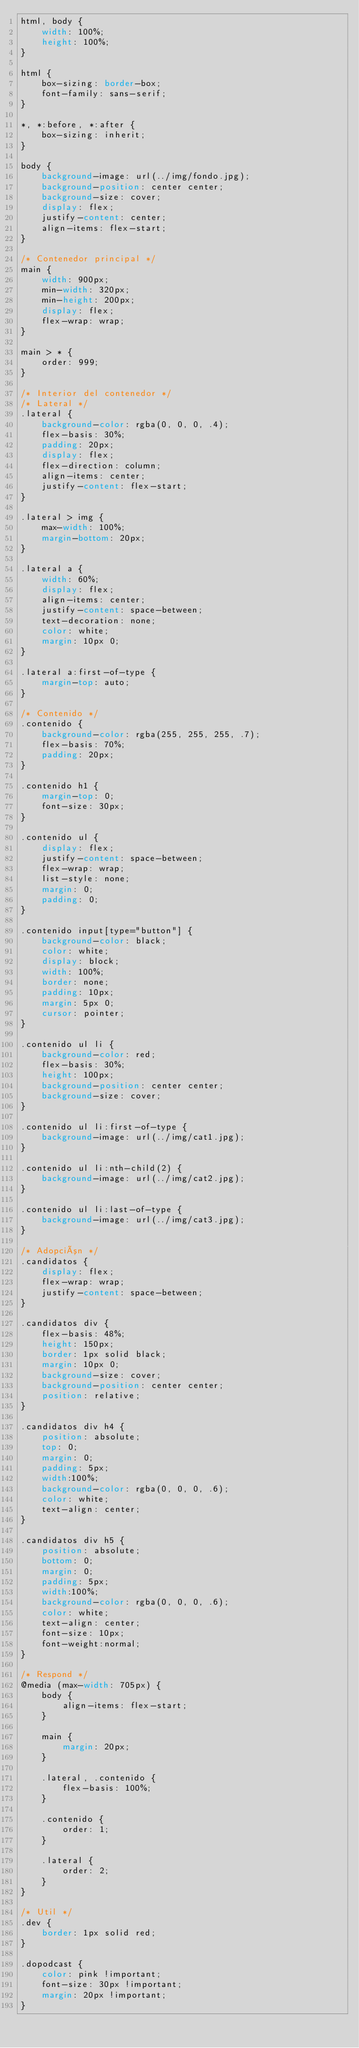<code> <loc_0><loc_0><loc_500><loc_500><_CSS_>html, body {
    width: 100%;
    height: 100%;
}

html {
    box-sizing: border-box;
    font-family: sans-serif;
}

*, *:before, *:after {
    box-sizing: inherit;
}

body {
    background-image: url(../img/fondo.jpg);
    background-position: center center;
    background-size: cover;
    display: flex;
    justify-content: center;
    align-items: flex-start;
}

/* Contenedor principal */
main {
    width: 900px;
    min-width: 320px;
    min-height: 200px;
    display: flex;
    flex-wrap: wrap;
}

main > * {
    order: 999;
}

/* Interior del contenedor */
/* Lateral */
.lateral {
    background-color: rgba(0, 0, 0, .4);
    flex-basis: 30%;
    padding: 20px;
    display: flex;
    flex-direction: column;
    align-items: center;
    justify-content: flex-start;
}

.lateral > img {
    max-width: 100%;
    margin-bottom: 20px;
}

.lateral a {
    width: 60%;
    display: flex;
    align-items: center;
    justify-content: space-between;
    text-decoration: none;
    color: white;
    margin: 10px 0;
}

.lateral a:first-of-type {
    margin-top: auto;
}

/* Contenido */
.contenido {
    background-color: rgba(255, 255, 255, .7);
    flex-basis: 70%;
    padding: 20px;
}

.contenido h1 {
    margin-top: 0;
    font-size: 30px;
}

.contenido ul {
    display: flex;
    justify-content: space-between;
    flex-wrap: wrap;
    list-style: none;
    margin: 0;
    padding: 0;
}

.contenido input[type="button"] {
    background-color: black;
    color: white;
    display: block;
    width: 100%;
    border: none;
    padding: 10px;
    margin: 5px 0;
    cursor: pointer;
}

.contenido ul li {
    background-color: red;
    flex-basis: 30%;
    height: 100px;
    background-position: center center;
    background-size: cover;
}

.contenido ul li:first-of-type {
    background-image: url(../img/cat1.jpg);
}

.contenido ul li:nth-child(2) {
    background-image: url(../img/cat2.jpg);
}

.contenido ul li:last-of-type {
    background-image: url(../img/cat3.jpg);
}

/* Adopción */
.candidatos {
    display: flex;
    flex-wrap: wrap;
    justify-content: space-between;
}

.candidatos div {
    flex-basis: 48%;
    height: 150px;
    border: 1px solid black;
    margin: 10px 0;
    background-size: cover;
    background-position: center center;
    position: relative;
}

.candidatos div h4 {
    position: absolute;
    top: 0;
    margin: 0;
    padding: 5px;
    width:100%;
    background-color: rgba(0, 0, 0, .6);
    color: white;
    text-align: center;
}

.candidatos div h5 {
    position: absolute;
    bottom: 0;
    margin: 0;
    padding: 5px;
    width:100%;
    background-color: rgba(0, 0, 0, .6);
    color: white;
    text-align: center;
    font-size: 10px;
    font-weight:normal;
}

/* Respond */
@media (max-width: 705px) {
    body {
        align-items: flex-start;
    }

    main {
        margin: 20px;
    }

    .lateral, .contenido {
        flex-basis: 100%;
    }

    .contenido {
        order: 1;
    }

    .lateral {
        order: 2;
    }
}

/* Util */
.dev {
    border: 1px solid red;
}

.dopodcast {
    color: pink !important;
    font-size: 30px !important;
    margin: 20px !important;
}

</code> 